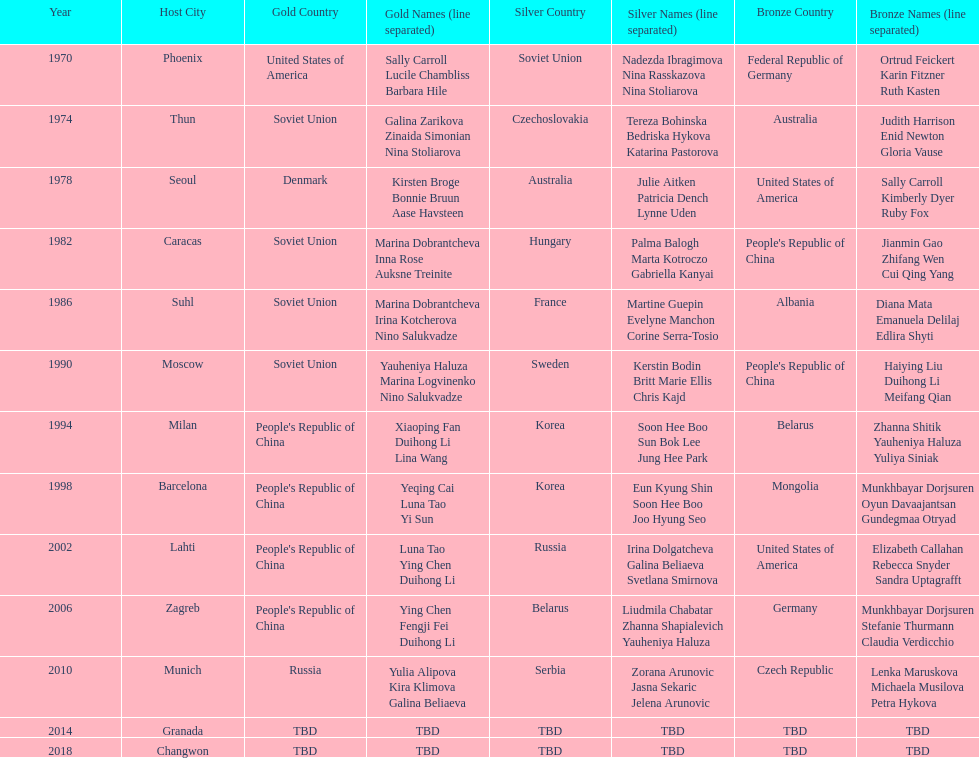Name one of the top three women to earn gold at the 1970 world championship held in phoenix, az Sally Carroll. 